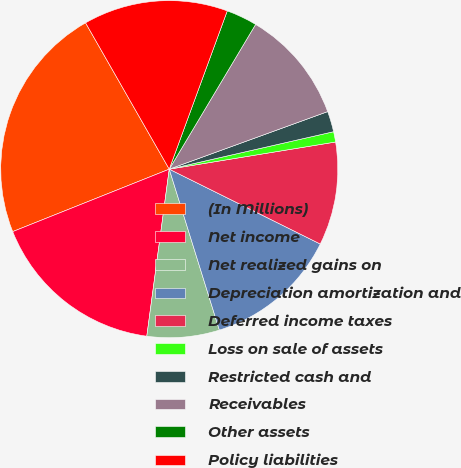Convert chart. <chart><loc_0><loc_0><loc_500><loc_500><pie_chart><fcel>(In Millions)<fcel>Net income<fcel>Net realized gains on<fcel>Depreciation amortization and<fcel>Deferred income taxes<fcel>Loss on sale of assets<fcel>Restricted cash and<fcel>Receivables<fcel>Other assets<fcel>Policy liabilities<nl><fcel>22.77%<fcel>16.83%<fcel>6.93%<fcel>12.87%<fcel>9.9%<fcel>0.99%<fcel>1.98%<fcel>10.89%<fcel>2.97%<fcel>13.86%<nl></chart> 